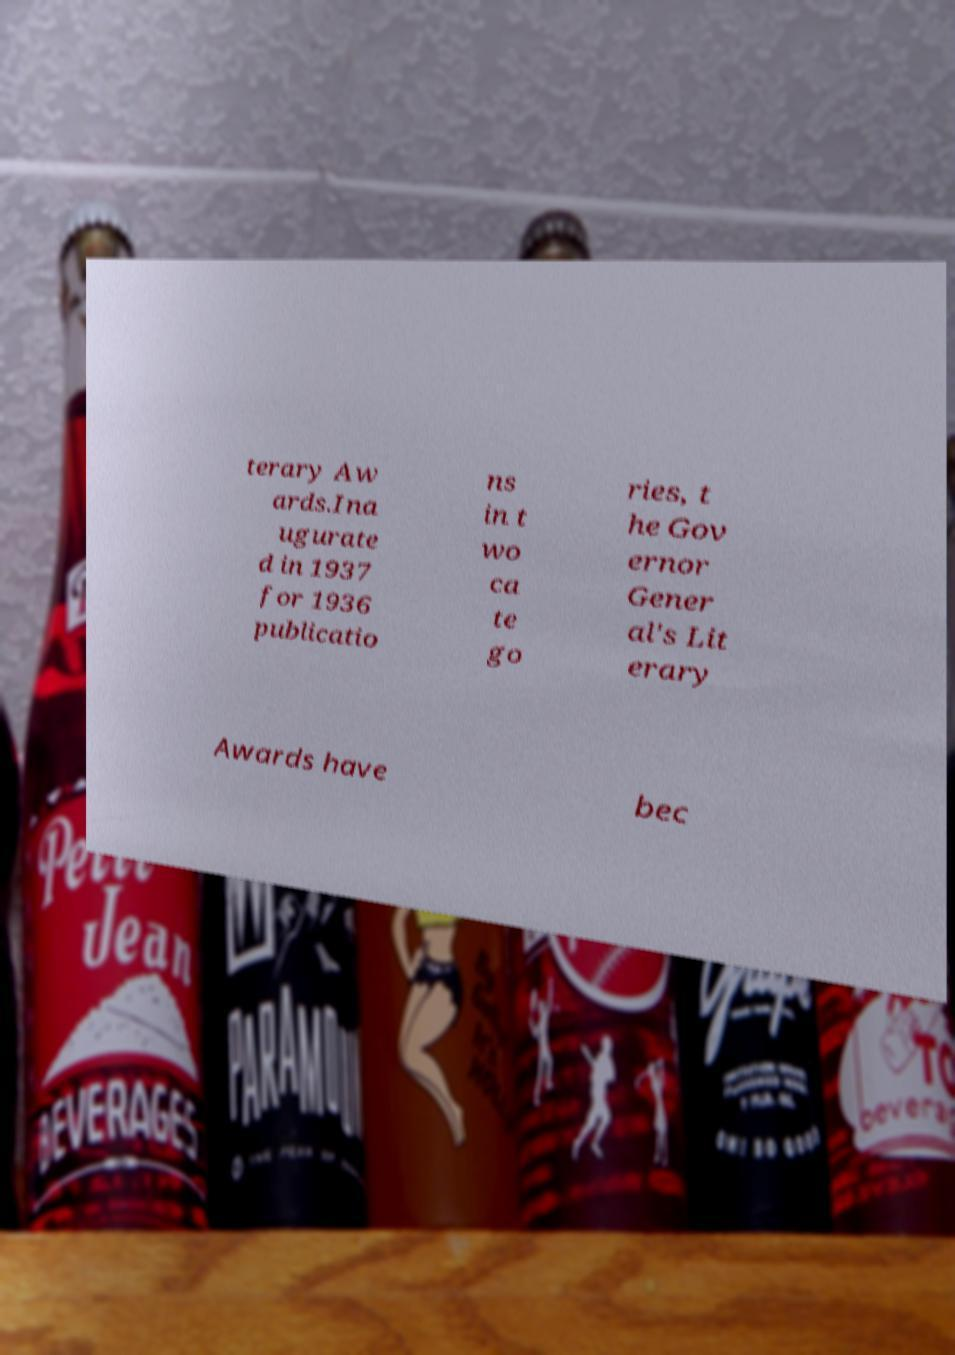Can you accurately transcribe the text from the provided image for me? terary Aw ards.Ina ugurate d in 1937 for 1936 publicatio ns in t wo ca te go ries, t he Gov ernor Gener al's Lit erary Awards have bec 